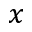Convert formula to latex. <formula><loc_0><loc_0><loc_500><loc_500>x</formula> 